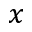Convert formula to latex. <formula><loc_0><loc_0><loc_500><loc_500>x</formula> 